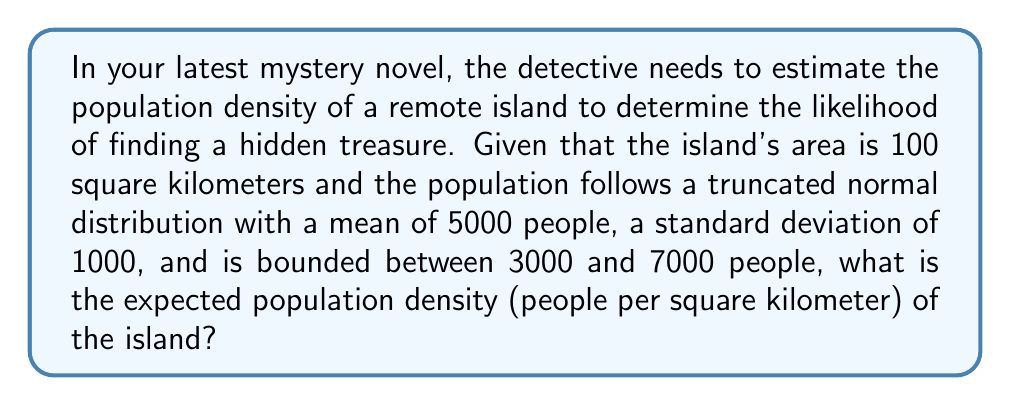Help me with this question. To solve this problem, we need to follow these steps:

1) First, we need to understand what a truncated normal distribution is. It's a normal distribution that is bounded on both sides. In this case, the population is bounded between 3000 and 7000 people.

2) For a truncated normal distribution, the expected value is not the same as the mean of the original normal distribution. We need to calculate the expected value of the truncated distribution.

3) The formula for the expected value of a truncated normal distribution is:

   $$E[X] = \mu + \frac{\phi(a) - \phi(b)}{\Phi(b) - \Phi(a)} \sigma$$

   Where:
   - $\mu$ is the mean of the original distribution (5000)
   - $\sigma$ is the standard deviation of the original distribution (1000)
   - $a = (3000 - 5000) / 1000 = -2$
   - $b = (7000 - 5000) / 1000 = 2$
   - $\phi$ is the standard normal probability density function
   - $\Phi$ is the standard normal cumulative distribution function

4) We need to calculate $\phi(a)$, $\phi(b)$, $\Phi(a)$, and $\Phi(b)$:

   $\phi(-2) \approx 0.0540$
   $\phi(2) \approx 0.0540$
   $\Phi(-2) \approx 0.0228$
   $\Phi(2) \approx 0.9772$

5) Plugging these values into the formula:

   $$E[X] = 5000 + \frac{0.0540 - 0.0540}{0.9772 - 0.0228} * 1000 = 5000$$

6) The expected population is 5000 people.

7) To find the population density, we divide the expected population by the area:

   $$\text{Density} = \frac{5000 \text{ people}}{100 \text{ km}^2} = 50 \text{ people/km}^2$$
Answer: The expected population density of the island is 50 people per square kilometer. 